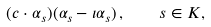<formula> <loc_0><loc_0><loc_500><loc_500>( c \cdot \alpha _ { s } ) ( \alpha _ { s } - \iota \alpha _ { s } ) \, , \quad s \in K ,</formula> 